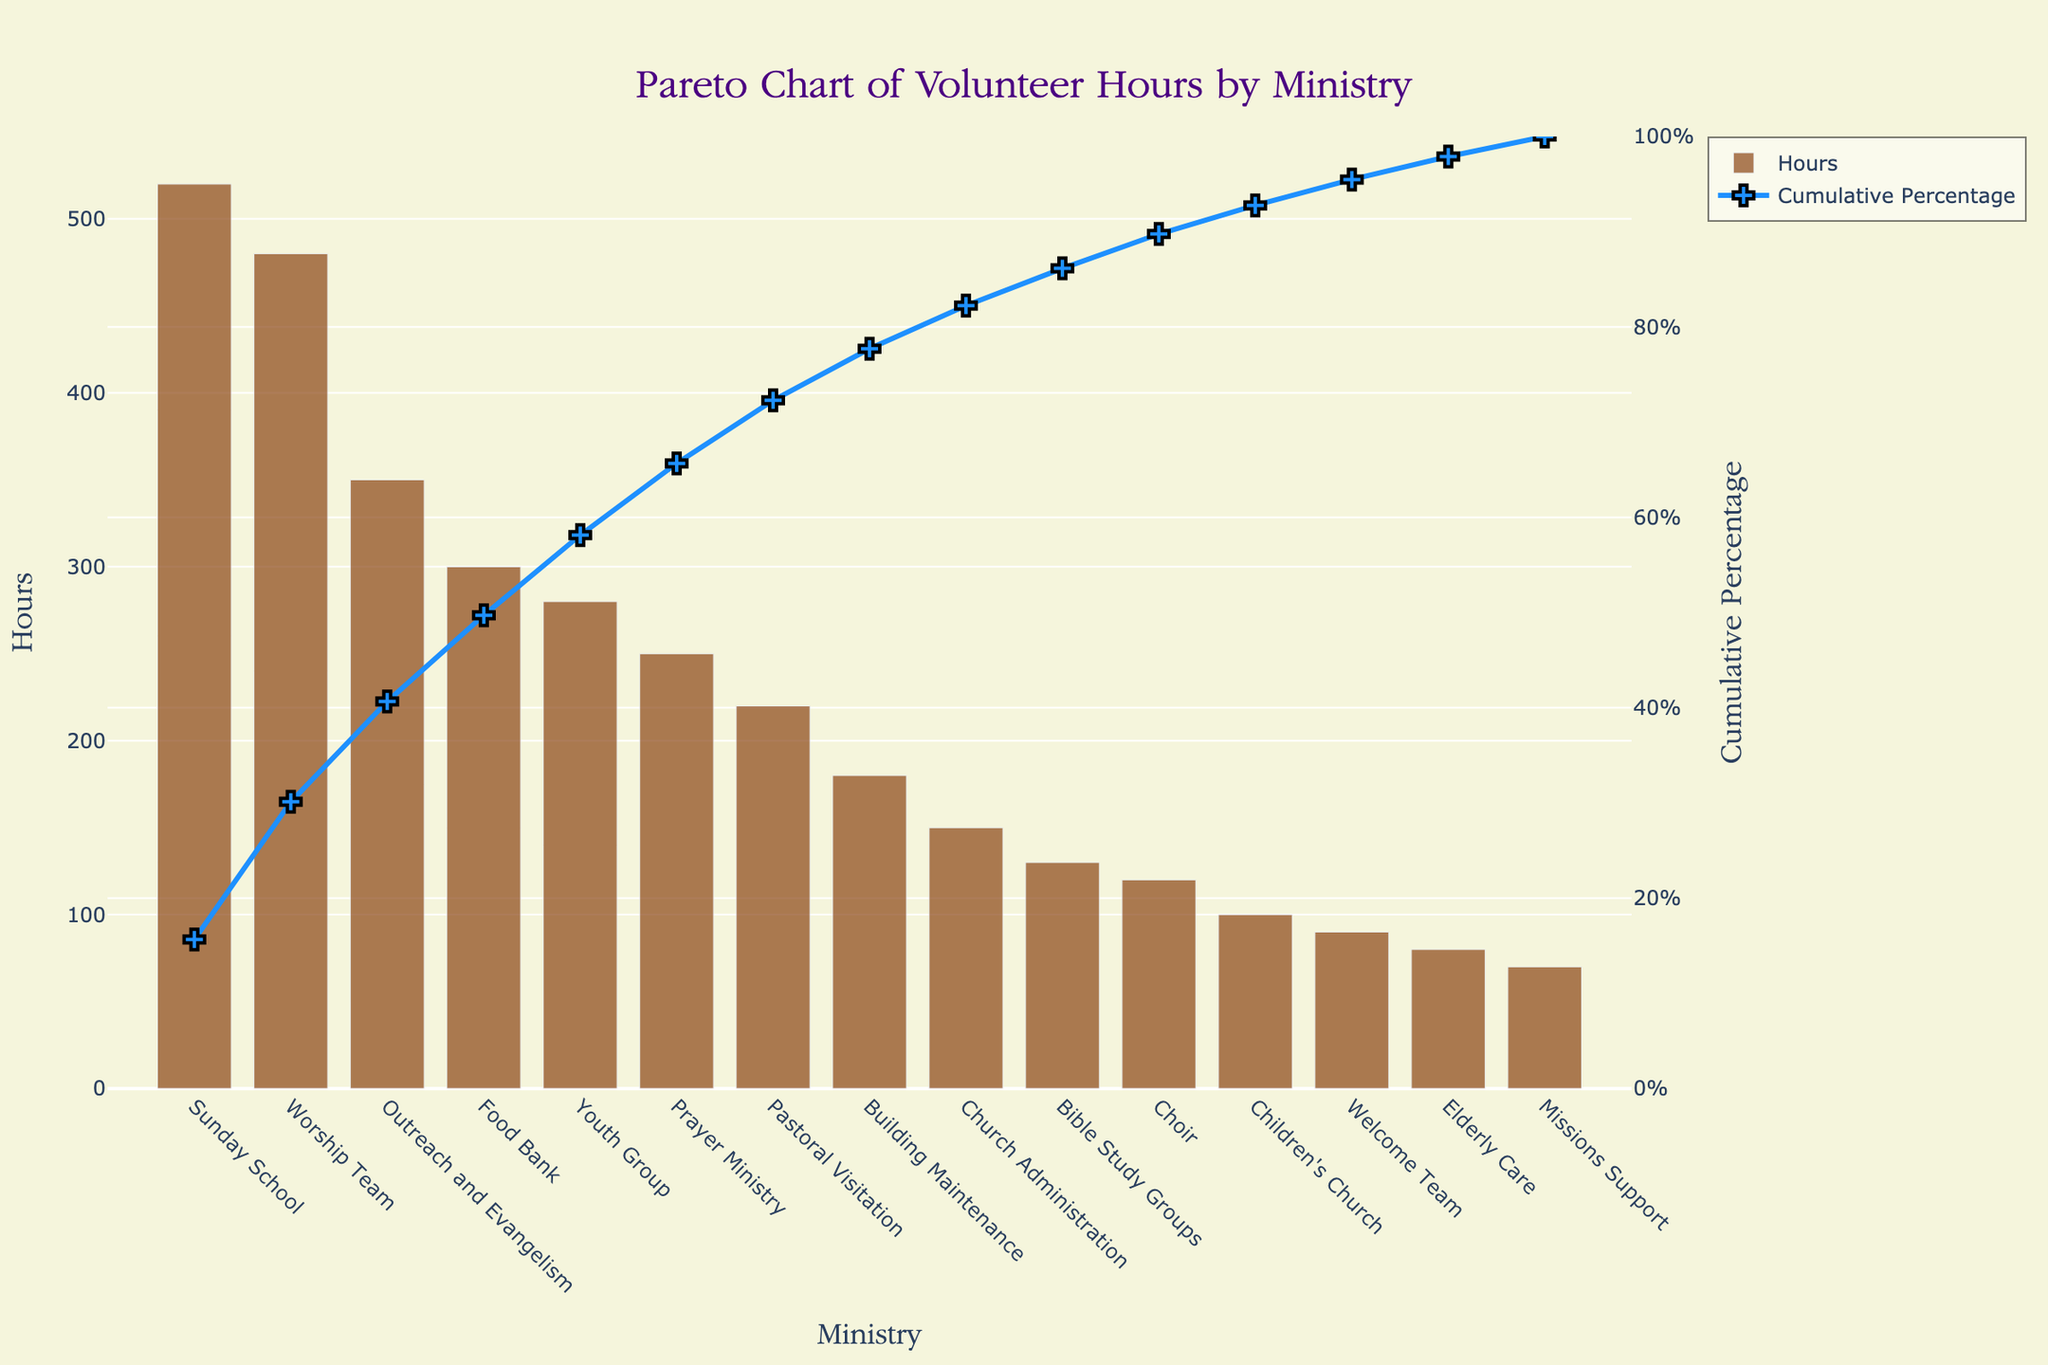What is the title of the chart? The title is displayed prominently at the top of the figure, and it reads: "Pareto Chart of Volunteer Hours by Ministry".
Answer: Pareto Chart of Volunteer Hours by Ministry Which ministry has the highest number of volunteer hours? The first bar of the chart, which represents "Sunday School," has the tallest height, indicating the highest number of volunteer hours, which is 520 hours.
Answer: Sunday School What is the cumulative percentage for the Worship Team? Locate the "Worship Team" bar on the x-axis and then refer to the corresponding point on the cumulative percentage line. According to the plot, the cumulative percentage for the Worship Team is reached at around 44%.
Answer: ~44% How many ministries contribute to 80% of the total volunteer hours? Follow the cumulative percentage line to find the point where it reaches 80%. Count the number of ministries up to this point. Based on the chart, it appears that about six ministries (Sunday School, Worship Team, Outreach and Evangelism, Food Bank, Youth Group, Prayer Ministry) reach around 80%.
Answer: 6 ministries Which ministry has the lowest number of volunteer hours? The last bar on the x-axis corresponds to "Missions Support," showing the lowest number of volunteer hours, which is 70 hours.
Answer: Missions Support What is the combined total volunteer hours contributed by the top three ministries? Sum the hours of the top three ministries: Sunday School (520), Worship Team (480), Outreach and Evangelism (350). So, 520 + 480 + 350 = 1350 hours.
Answer: 1350 hours Is the cumulative percentage line rising faster at the beginning or towards the end? The cumulative percentage line is steeper at the beginning, indicating a faster rise in the percentage, which shows more hours contributed by fewer ministries initially.
Answer: Beginning By how much do the volunteer hours contributed by "Youth Group" exceed those contributed by "Elderly Care"? Subtract the hours for Elderly Care (80) from the Youth Group (280): 280 - 80 = 200 hours.
Answer: 200 hours What percentage of the total volunteer hours do the "Prayer Ministry" and "Pastoral Visitation" together contribute? Sum the hours for Prayer Ministry (250) and Pastoral Visitation (220), then divide by the total hours and multiply by 100 to find the percentage: (250 + 220) / 3420 * 100 ≈ 13.79%.
Answer: ~13.79% 